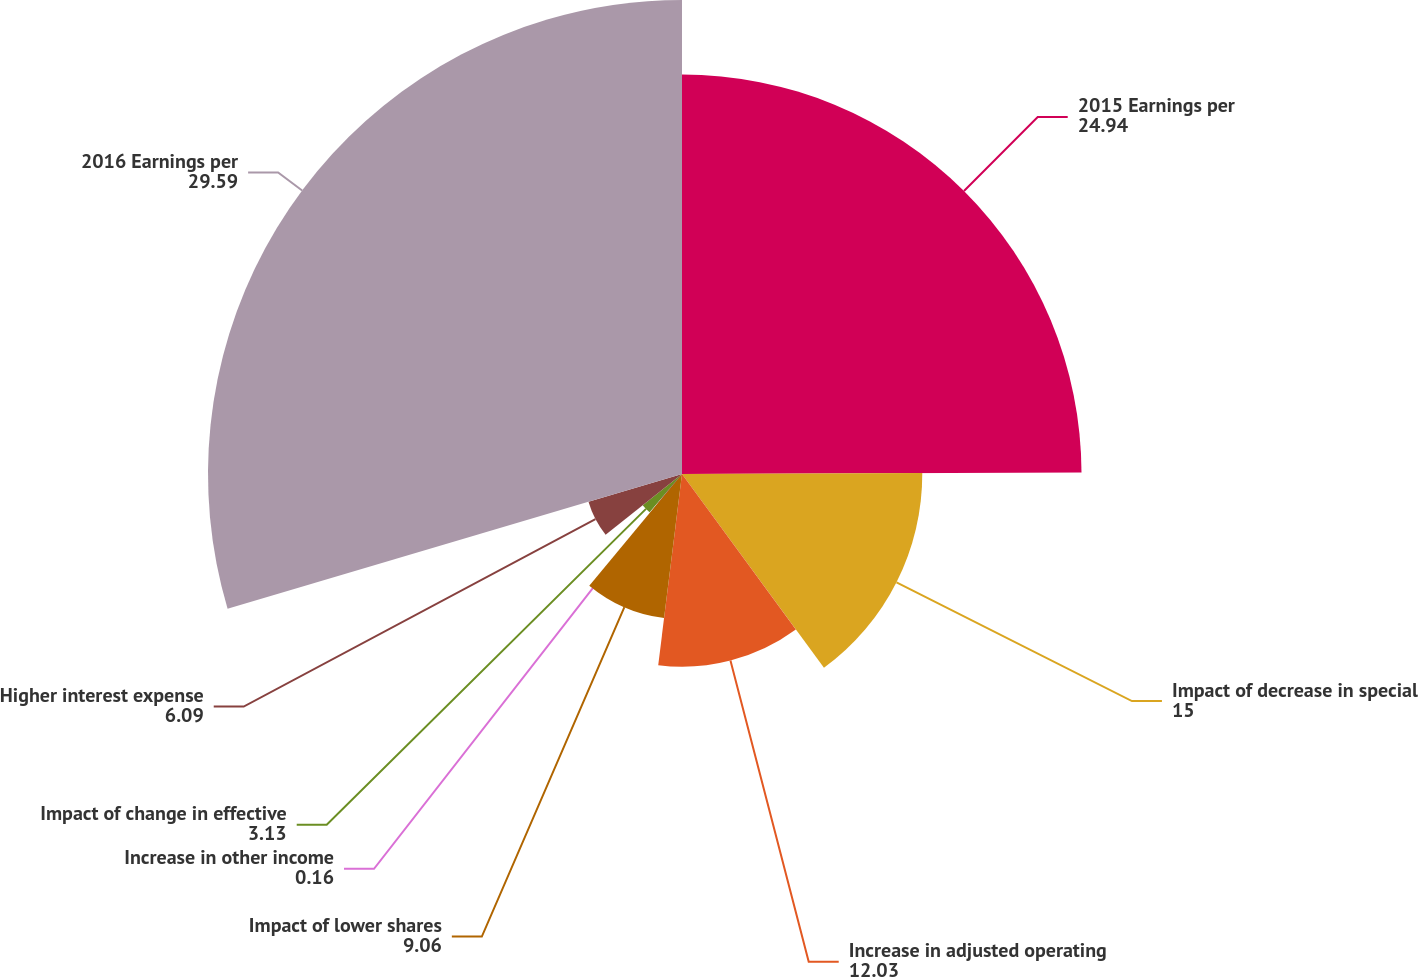Convert chart to OTSL. <chart><loc_0><loc_0><loc_500><loc_500><pie_chart><fcel>2015 Earnings per<fcel>Impact of decrease in special<fcel>Increase in adjusted operating<fcel>Impact of lower shares<fcel>Increase in other income<fcel>Impact of change in effective<fcel>Higher interest expense<fcel>2016 Earnings per<nl><fcel>24.94%<fcel>15.0%<fcel>12.03%<fcel>9.06%<fcel>0.16%<fcel>3.13%<fcel>6.09%<fcel>29.59%<nl></chart> 